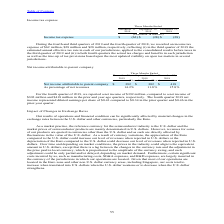According to Stmicroelectronics's financial document, How much was the income tax expense in the fourth quarter of 2019? According to the financial document, $62 million. The relevant text states: "rter of 2018, we recorded an income tax expense of $62 million, $28 million and $28 million, respectively, reflecting (i) in the third quarter of 2019 the estimat..." Also, What does the income tax expense in the third quarter of 2019, reflect? in the third quarter of 2019 the estimated annual effective tax rate in each of our jurisdictions, applied to the consolidated results before taxes in the third quarter of 2019. The document states: "ion and $28 million, respectively, reflecting (i) in the third quarter of 2019 the estimated annual effective tax rate in each of our jurisdictions, a..." Also, What does the income tax expense in the fourth quarter of 2018 and 2019, reflect? in both fourth quarters the actual tax charges and benefits in each jurisdiction as well as the true-up of tax provisions based upon the most updated visibility on open tax matters in several jurisdictions.. The document states: "before taxes in the third quarter of 2019 and (ii) in both fourth quarters the actual tax charges and benefits in each jurisdiction as well as the tru..." Also, can you calculate: What is the average Income tax expense for the period September 29, and December 31, 2019? To answer this question, I need to perform calculations using the financial data. The calculation is: (62+28) / 2, which equals 45 (in millions). This is based on the information: "Income tax expense $ (62) $ (28) $ (28) Income tax expense $ (62) $ (28) $ (28)..." The key data points involved are: 28, 62. Also, can you calculate: What is the average Income tax expense for the period December 31, 2019 and 2018? To answer this question, I need to perform calculations using the financial data. The calculation is: (62+28) / 2, which equals 45 (in millions). This is based on the information: "Income tax expense $ (62) $ (28) $ (28) Income tax expense $ (62) $ (28) $ (28)..." The key data points involved are: 28, 62. Also, can you calculate: What is the increase/ (decrease) in Income tax expense from the period December 31, 2018 to 2019? Based on the calculation: 62-28, the result is 34 (in millions). This is based on the information: "Income tax expense $ (62) $ (28) $ (28) Income tax expense $ (62) $ (28) $ (28)..." The key data points involved are: 28, 62. 